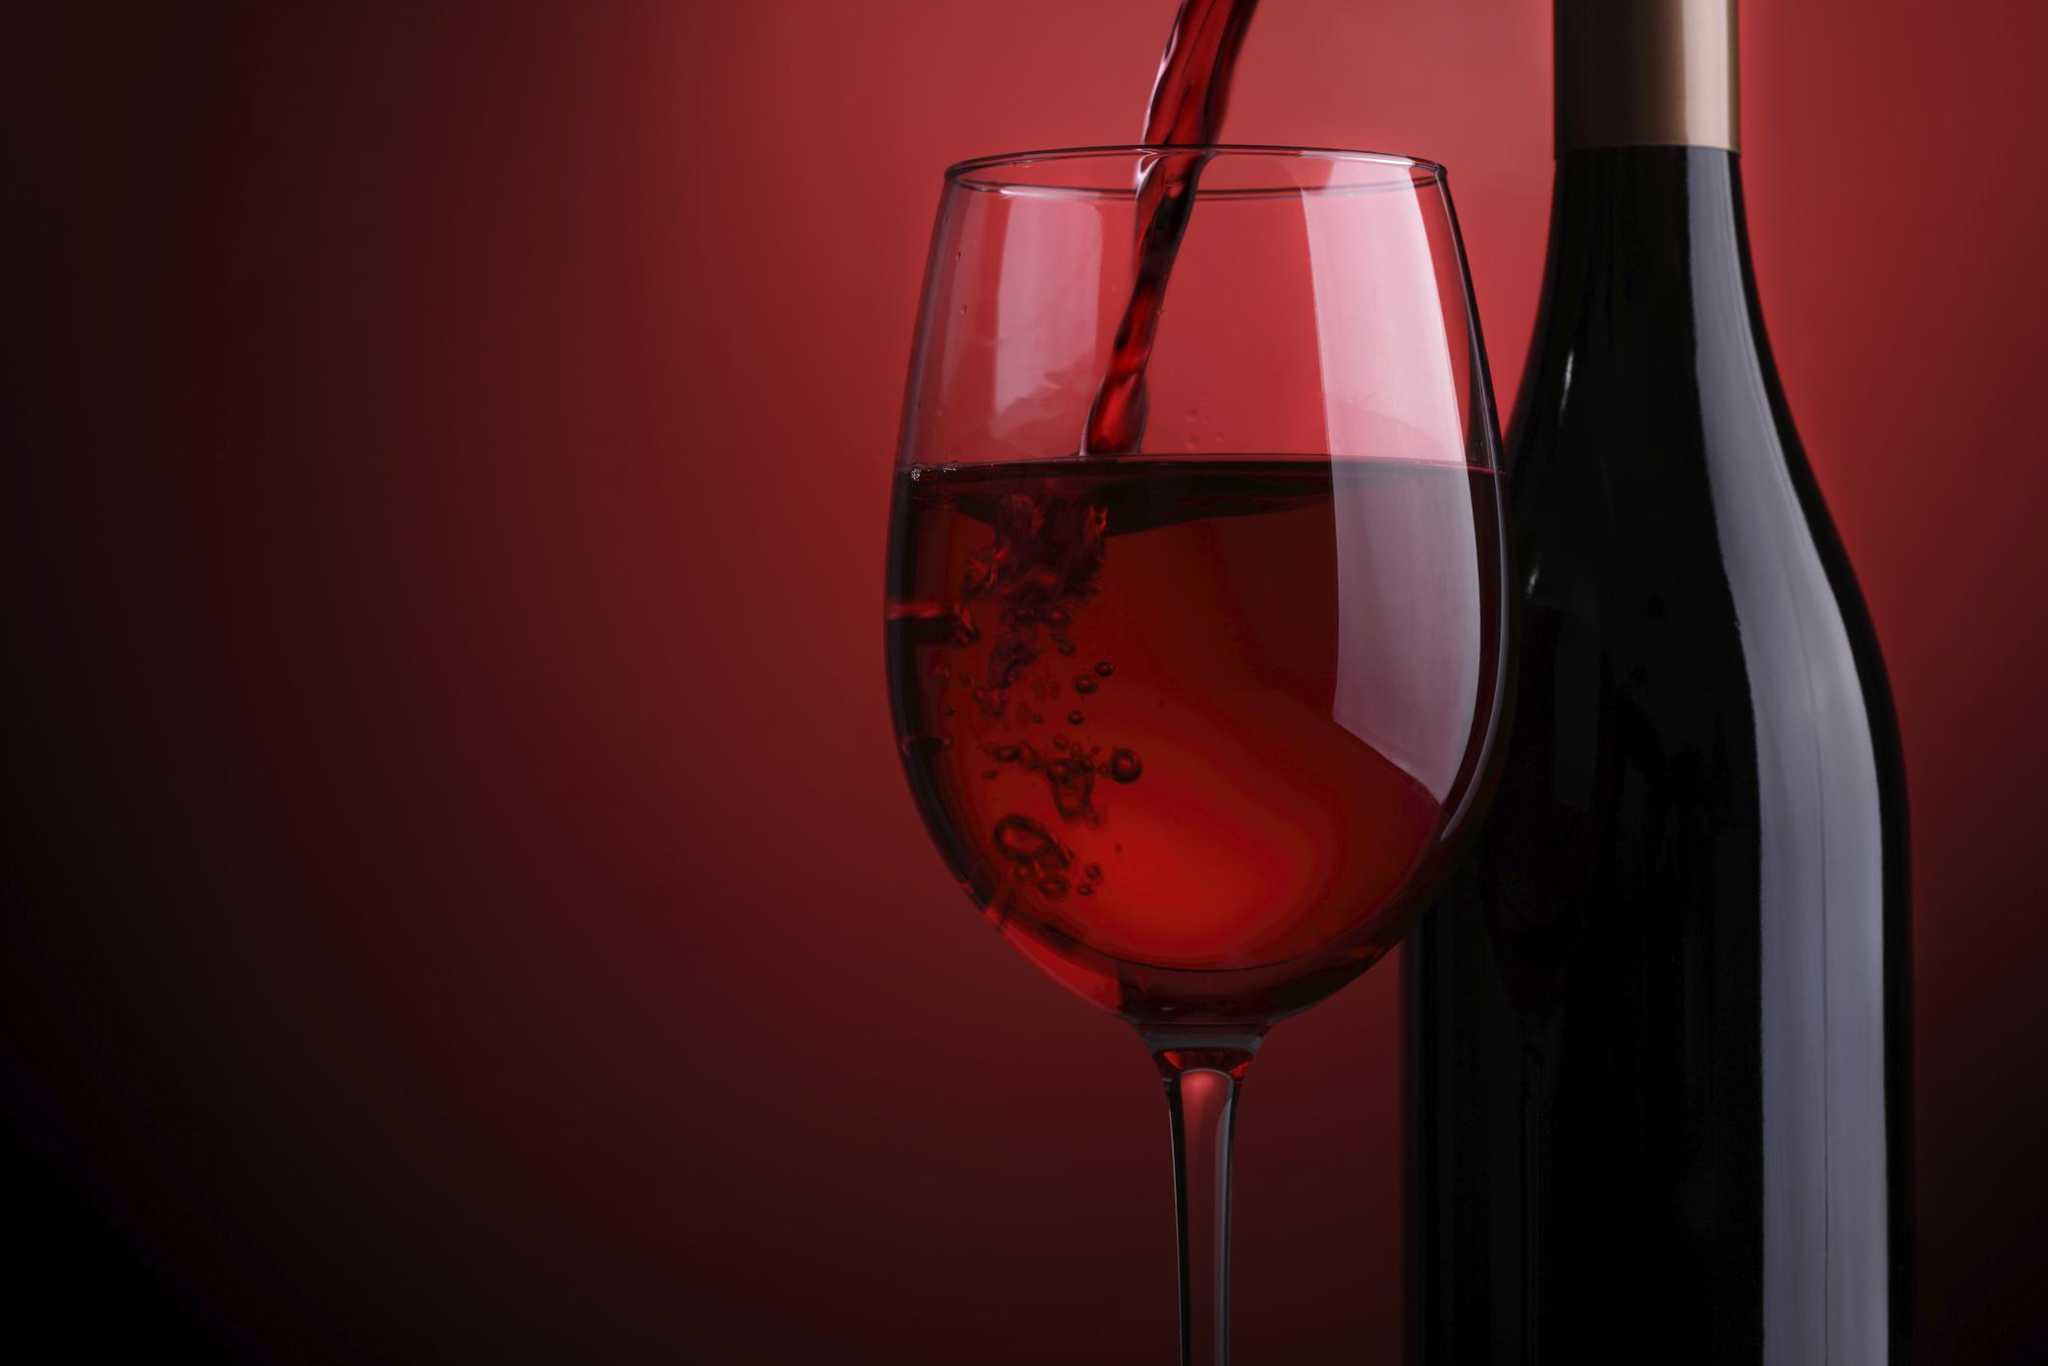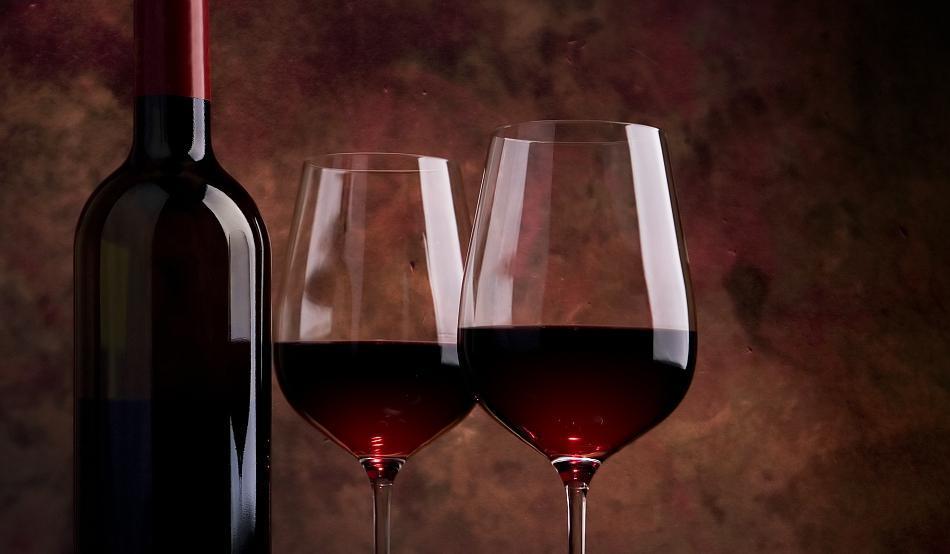The first image is the image on the left, the second image is the image on the right. Examine the images to the left and right. Is the description "There are exactly three glasses filled with red wine" accurate? Answer yes or no. Yes. The first image is the image on the left, the second image is the image on the right. For the images shown, is this caption "An image shows wine flowing into a glass, which stands next to an upright bottle." true? Answer yes or no. Yes. 